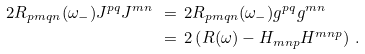Convert formula to latex. <formula><loc_0><loc_0><loc_500><loc_500>2 R _ { p m q n } ( \omega _ { - } ) J ^ { p q } J ^ { m n } \ & = \ 2 R _ { p m q n } ( \omega _ { - } ) g ^ { p q } g ^ { m n } \\ \ & = \ 2 \left ( R ( \omega ) - H _ { m n p } H ^ { m n p } \right ) \, .</formula> 